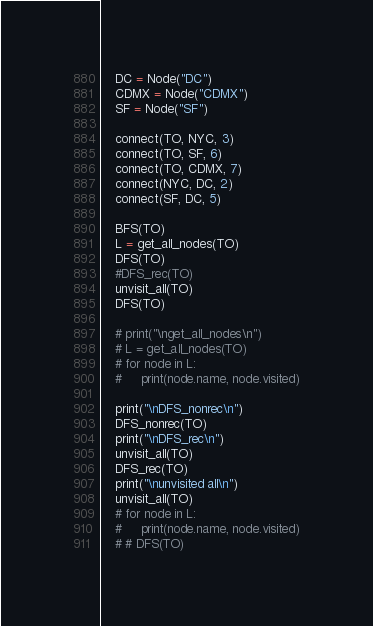<code> <loc_0><loc_0><loc_500><loc_500><_Python_>    DC = Node("DC")
    CDMX = Node("CDMX")
    SF = Node("SF")

    connect(TO, NYC, 3)
    connect(TO, SF, 6)
    connect(TO, CDMX, 7)
    connect(NYC, DC, 2)
    connect(SF, DC, 5)

    BFS(TO)
    L = get_all_nodes(TO)
    DFS(TO)
    #DFS_rec(TO)
    unvisit_all(TO)
    DFS(TO)

    # print("\nget_all_nodes\n")
    # L = get_all_nodes(TO)
    # for node in L:
    #     print(node.name, node.visited)

    print("\nDFS_nonrec\n")
    DFS_nonrec(TO)
    print("\nDFS_rec\n")
    unvisit_all(TO)
    DFS_rec(TO)
    print("\nunvisited all\n")
    unvisit_all(TO)
    # for node in L:
    #     print(node.name, node.visited)
    # # DFS(TO)
</code> 